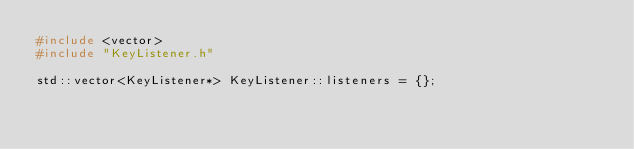Convert code to text. <code><loc_0><loc_0><loc_500><loc_500><_C++_>#include <vector>
#include "KeyListener.h"

std::vector<KeyListener*> KeyListener::listeners = {};</code> 